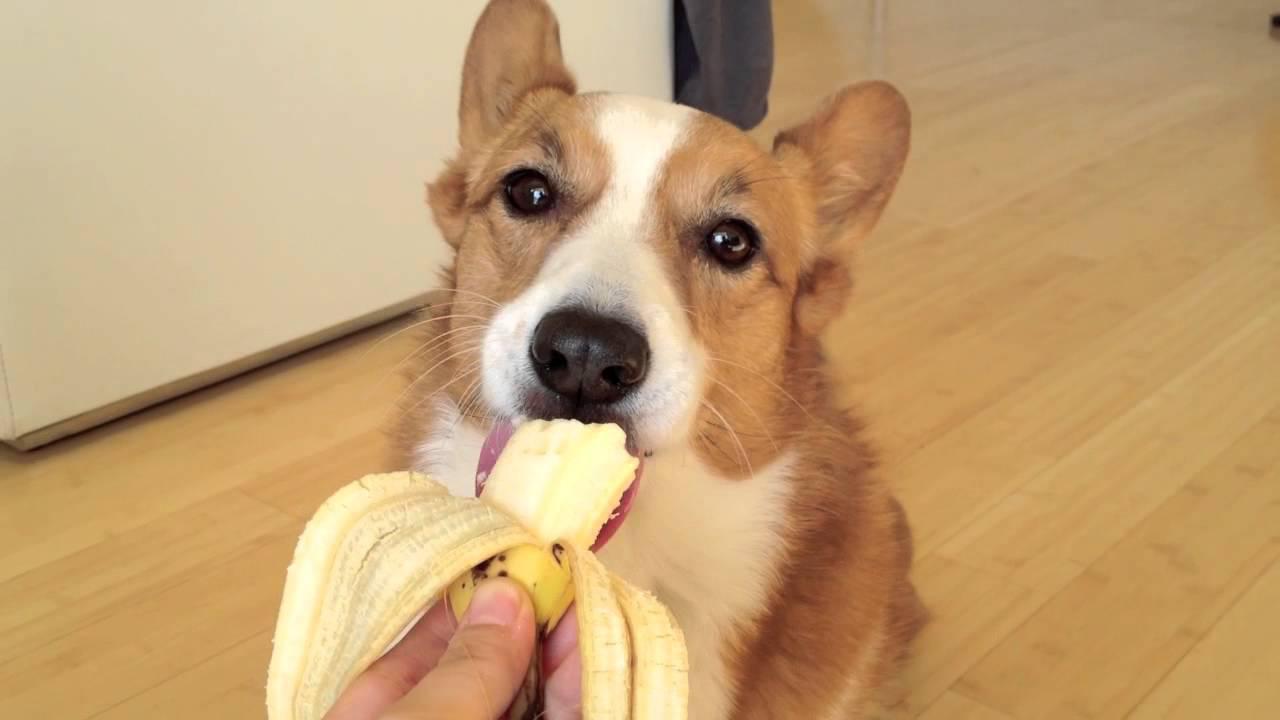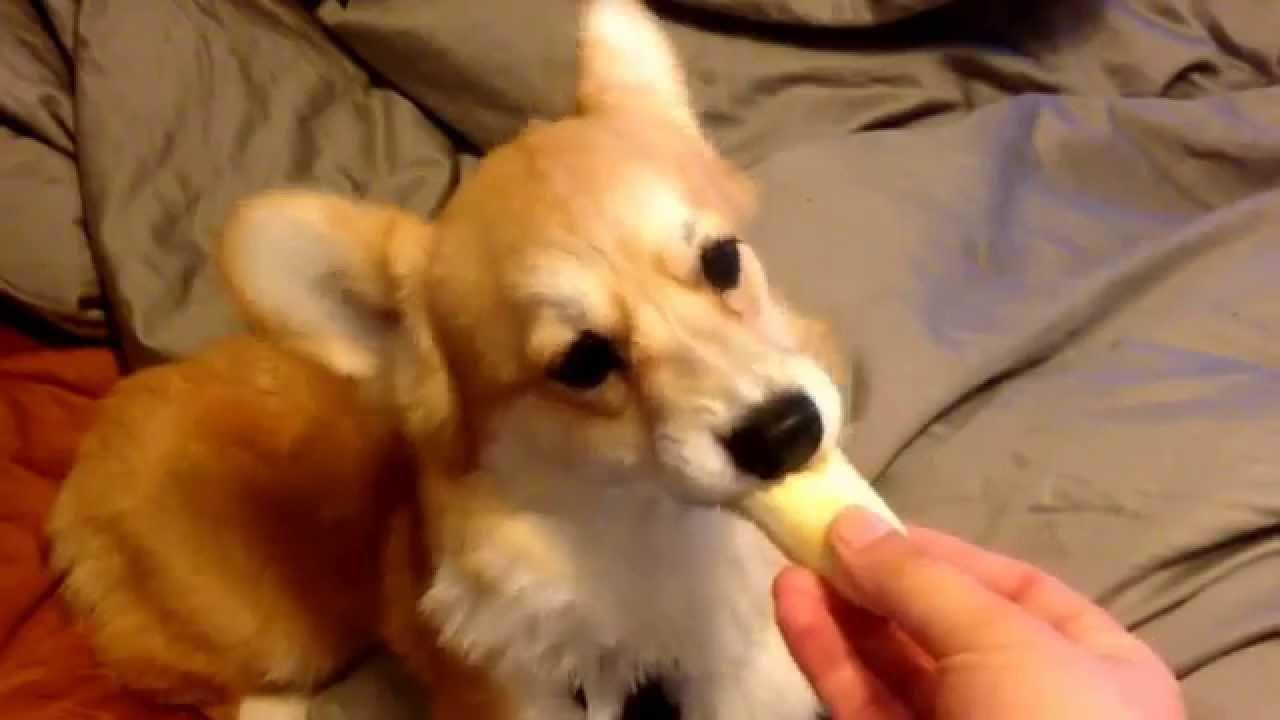The first image is the image on the left, the second image is the image on the right. For the images displayed, is the sentence "there is a dog and a chicken  in a dirt yard" factually correct? Answer yes or no. No. The first image is the image on the left, the second image is the image on the right. Analyze the images presented: Is the assertion "In one of the images there is a dog facing a chicken." valid? Answer yes or no. No. 